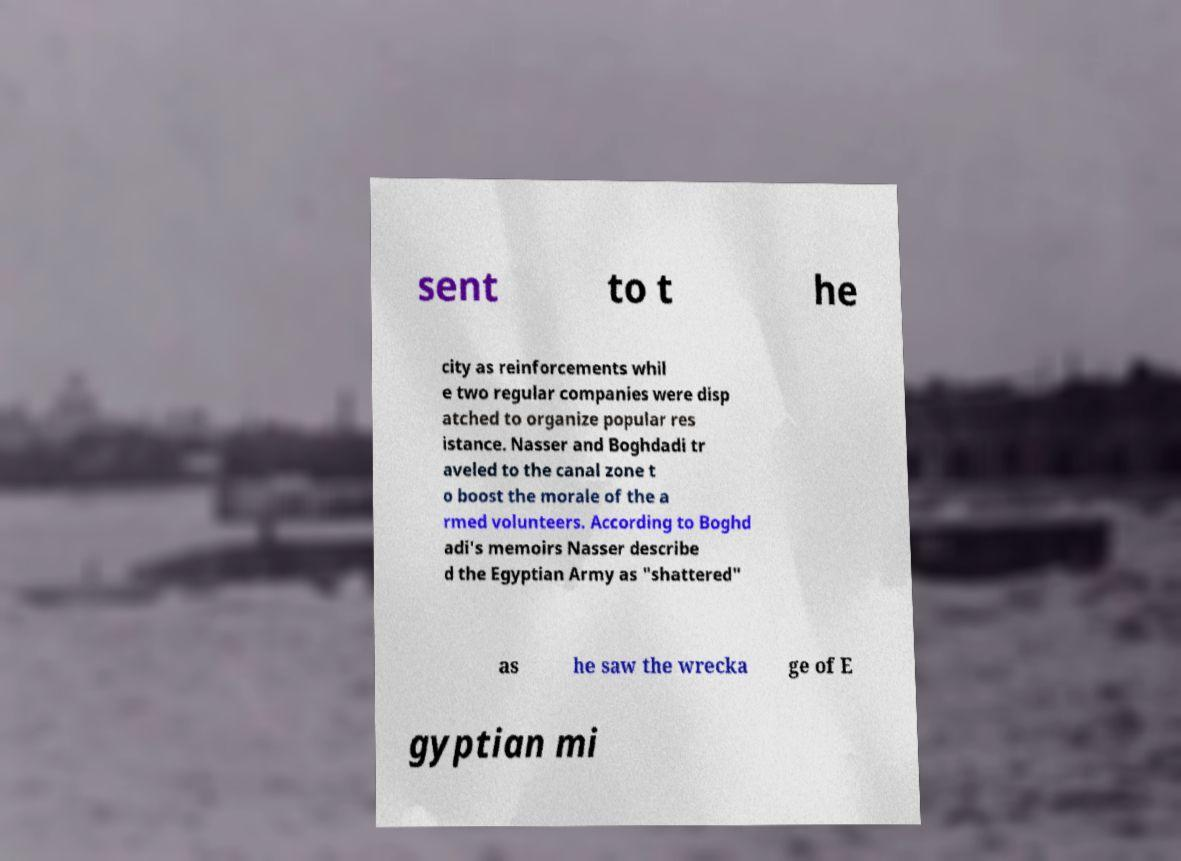For documentation purposes, I need the text within this image transcribed. Could you provide that? sent to t he city as reinforcements whil e two regular companies were disp atched to organize popular res istance. Nasser and Boghdadi tr aveled to the canal zone t o boost the morale of the a rmed volunteers. According to Boghd adi's memoirs Nasser describe d the Egyptian Army as "shattered" as he saw the wrecka ge of E gyptian mi 